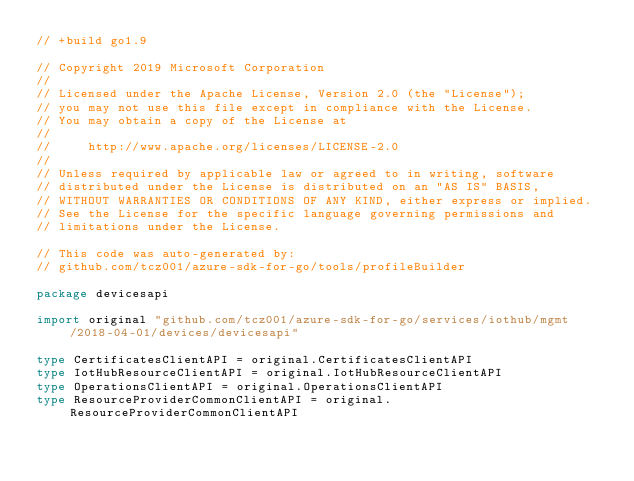<code> <loc_0><loc_0><loc_500><loc_500><_Go_>// +build go1.9

// Copyright 2019 Microsoft Corporation
//
// Licensed under the Apache License, Version 2.0 (the "License");
// you may not use this file except in compliance with the License.
// You may obtain a copy of the License at
//
//     http://www.apache.org/licenses/LICENSE-2.0
//
// Unless required by applicable law or agreed to in writing, software
// distributed under the License is distributed on an "AS IS" BASIS,
// WITHOUT WARRANTIES OR CONDITIONS OF ANY KIND, either express or implied.
// See the License for the specific language governing permissions and
// limitations under the License.

// This code was auto-generated by:
// github.com/tcz001/azure-sdk-for-go/tools/profileBuilder

package devicesapi

import original "github.com/tcz001/azure-sdk-for-go/services/iothub/mgmt/2018-04-01/devices/devicesapi"

type CertificatesClientAPI = original.CertificatesClientAPI
type IotHubResourceClientAPI = original.IotHubResourceClientAPI
type OperationsClientAPI = original.OperationsClientAPI
type ResourceProviderCommonClientAPI = original.ResourceProviderCommonClientAPI
</code> 